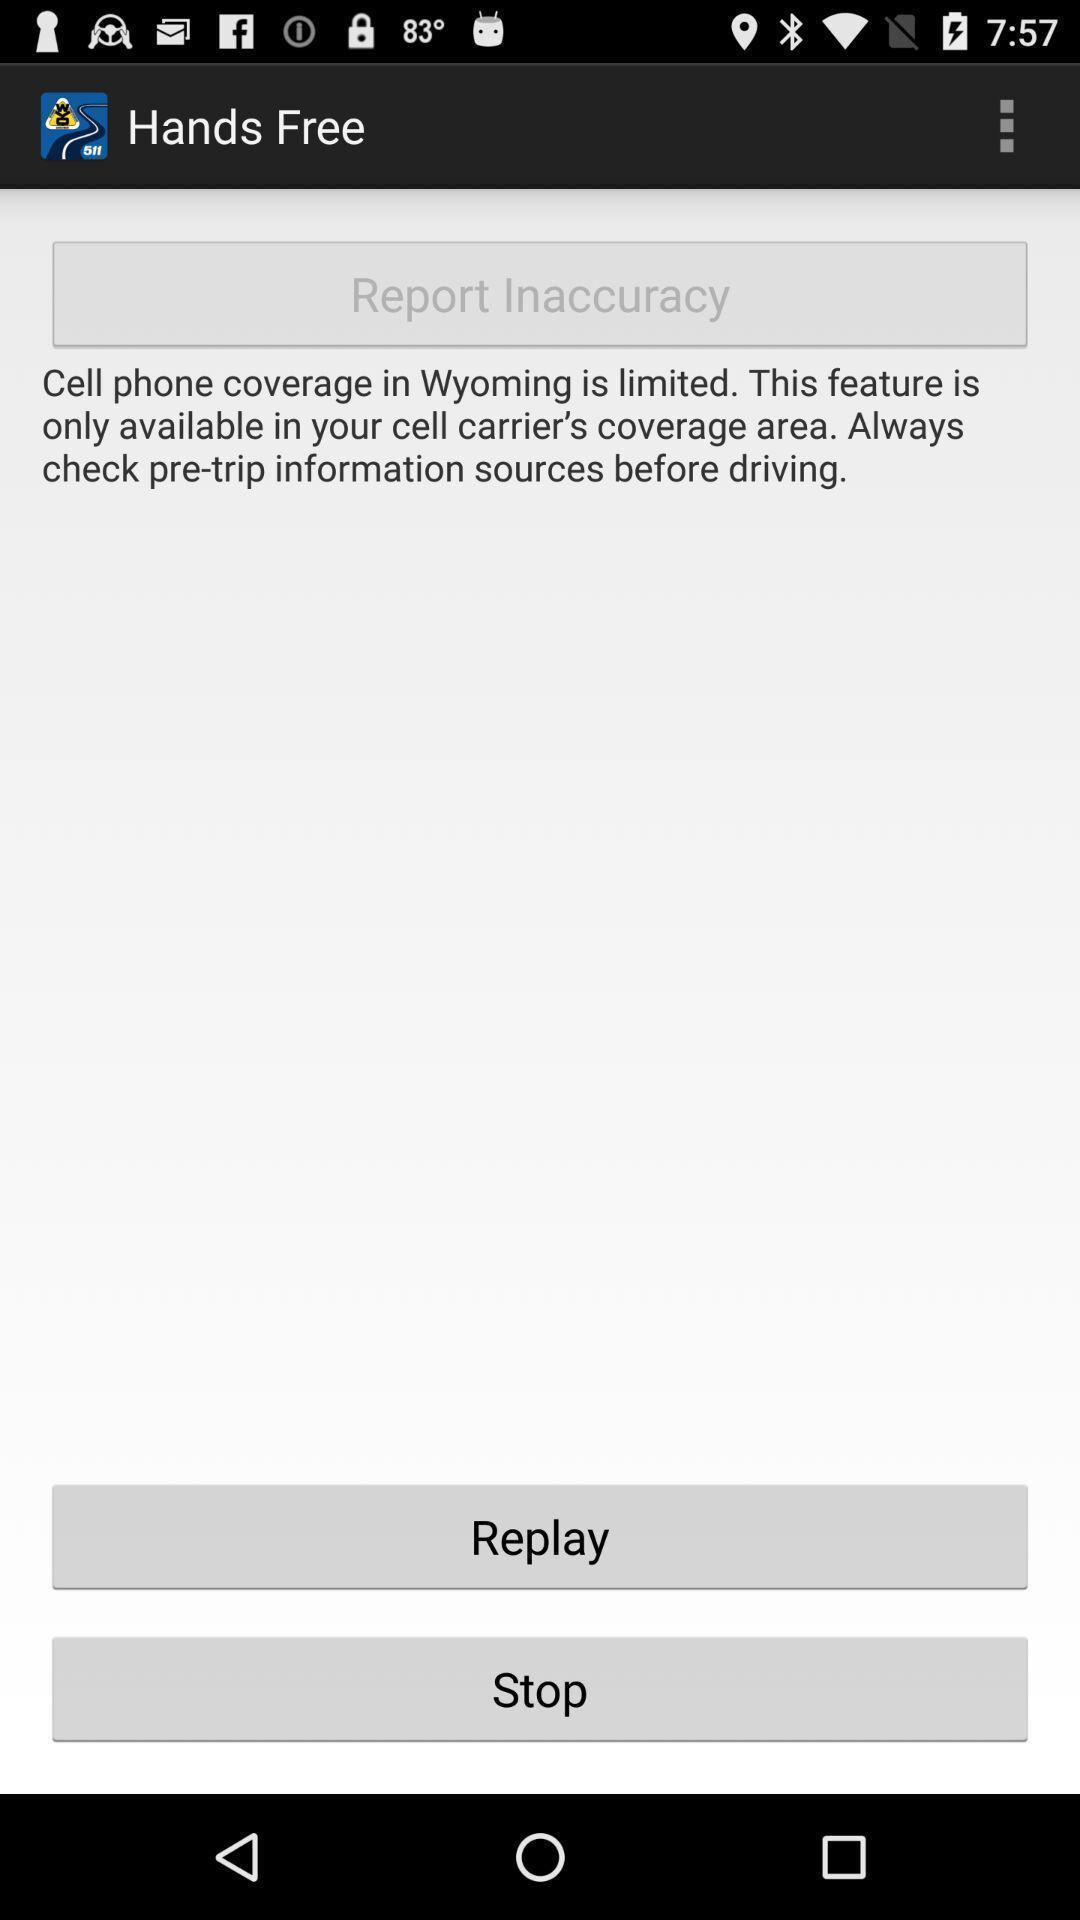Tell me what you see in this picture. Page shows the replay or stop option of the report. 